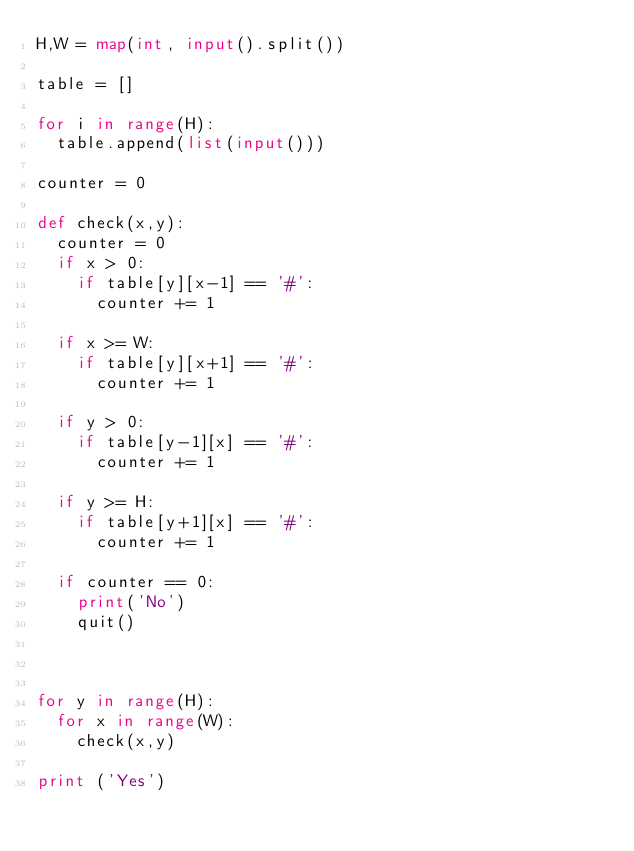<code> <loc_0><loc_0><loc_500><loc_500><_Python_>H,W = map(int, input().split())

table = []

for i in range(H):
	table.append(list(input()))

counter = 0
	
def check(x,y):
	counter = 0
	if x > 0:
		if table[y][x-1] == '#':
			counter += 1
			
	if x >= W:
		if table[y][x+1] == '#':
			counter += 1
	
	if y > 0:
		if table[y-1][x] == '#':
			counter += 1
	
	if y >= H:
		if table[y+1][x] == '#':
			counter += 1
	
	if counter == 0:
		print('No')
		quit()
			
	

for y in range(H):
	for x in range(W):
		check(x,y)

print ('Yes')	</code> 